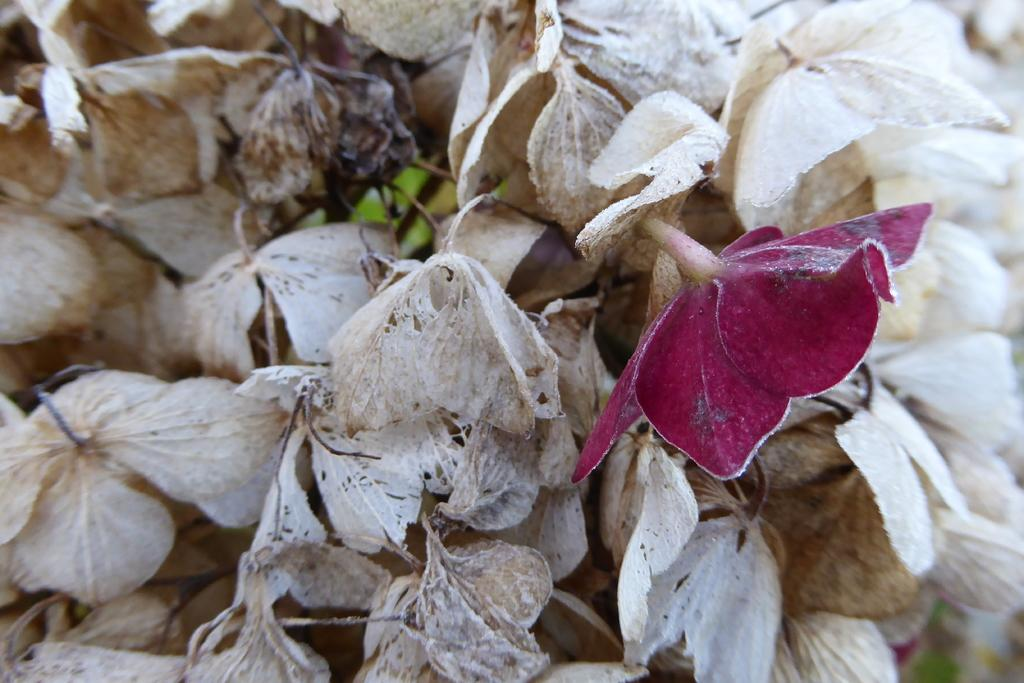What type of plants can be seen in the image? There are flowers in the image. How many different colors do the flowers have? The flowers are in two different colors. What type of fowl can be seen in the image? There is no fowl present in the image; it only features flowers. Is there a shop visible in the image? There is no shop present in the image; it only features flowers. 